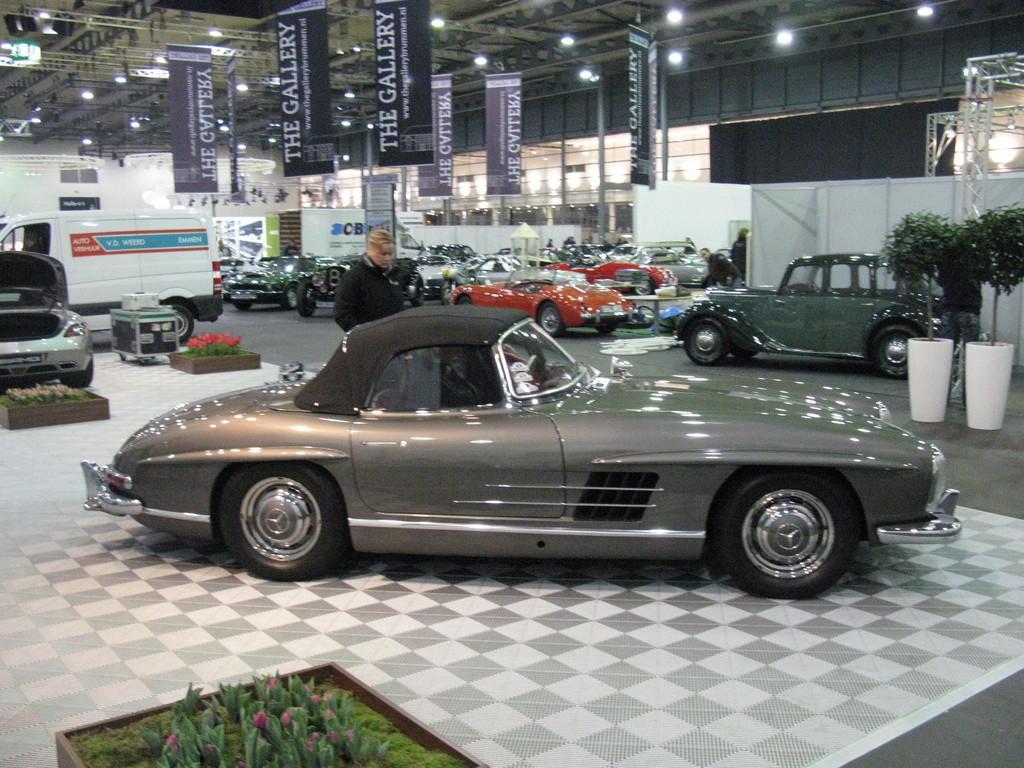Describe this image in one or two sentences. I think this picture was taken inside the showroom. These are the banners hanging. Here is a person standing. There are different model cars and vans. I think these are the flower pots with the plants in it. I can see the ceiling lights at the top. 